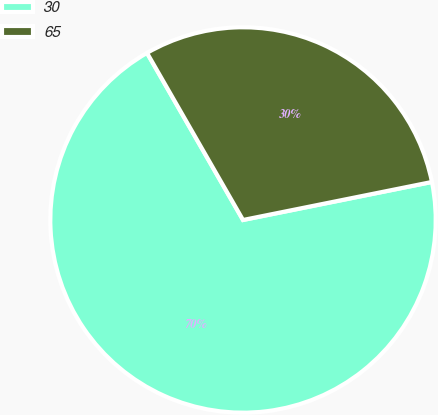Convert chart. <chart><loc_0><loc_0><loc_500><loc_500><pie_chart><fcel>30<fcel>65<nl><fcel>69.86%<fcel>30.14%<nl></chart> 